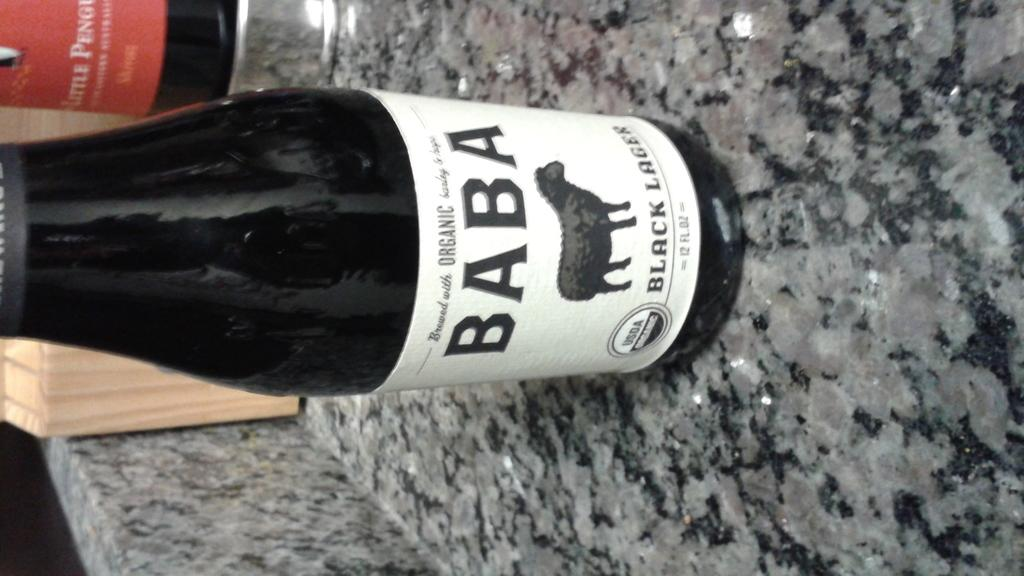<image>
Give a short and clear explanation of the subsequent image. The bottle of BABA indicates it is an organic beer. 